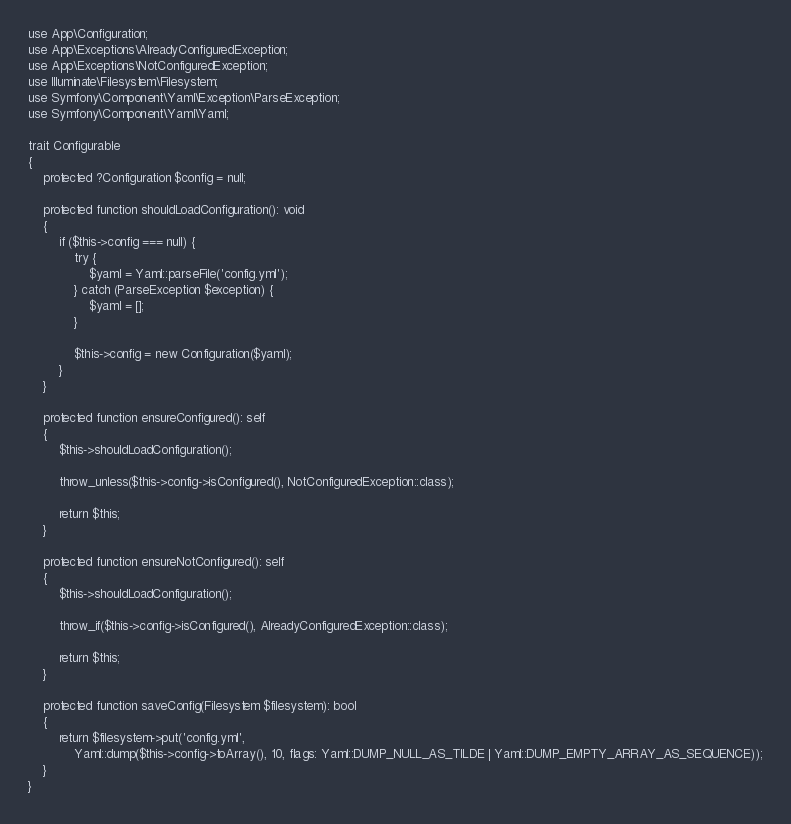Convert code to text. <code><loc_0><loc_0><loc_500><loc_500><_PHP_>use App\Configuration;
use App\Exceptions\AlreadyConfiguredException;
use App\Exceptions\NotConfiguredException;
use Illuminate\Filesystem\Filesystem;
use Symfony\Component\Yaml\Exception\ParseException;
use Symfony\Component\Yaml\Yaml;

trait Configurable
{
    protected ?Configuration $config = null;

    protected function shouldLoadConfiguration(): void
    {
        if ($this->config === null) {
            try {
                $yaml = Yaml::parseFile('config.yml');
            } catch (ParseException $exception) {
                $yaml = [];
            }

            $this->config = new Configuration($yaml);
        }
    }

    protected function ensureConfigured(): self
    {
        $this->shouldLoadConfiguration();

        throw_unless($this->config->isConfigured(), NotConfiguredException::class);

        return $this;
    }

    protected function ensureNotConfigured(): self
    {
        $this->shouldLoadConfiguration();

        throw_if($this->config->isConfigured(), AlreadyConfiguredException::class);

        return $this;
    }

    protected function saveConfig(Filesystem $filesystem): bool
    {
        return $filesystem->put('config.yml',
            Yaml::dump($this->config->toArray(), 10, flags: Yaml::DUMP_NULL_AS_TILDE | Yaml::DUMP_EMPTY_ARRAY_AS_SEQUENCE));
    }
}
</code> 